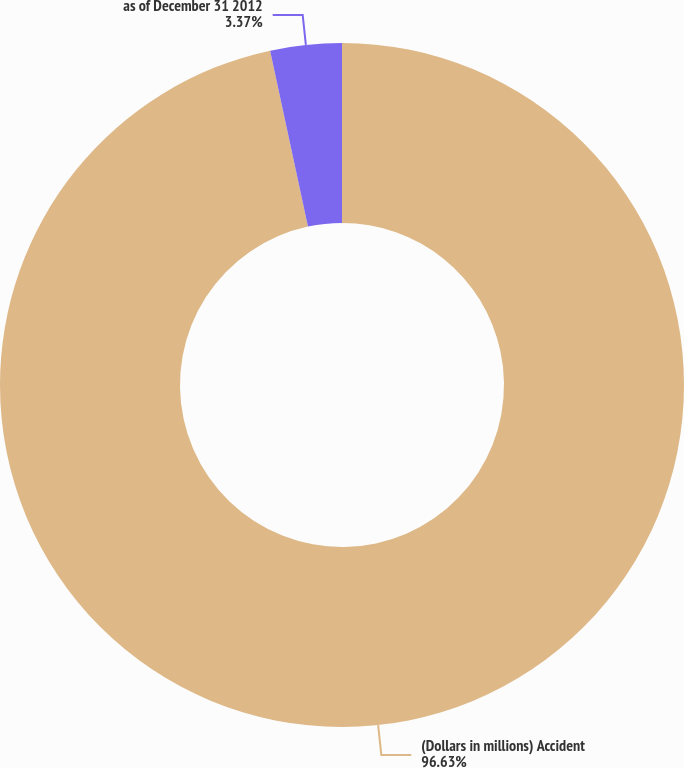<chart> <loc_0><loc_0><loc_500><loc_500><pie_chart><fcel>(Dollars in millions) Accident<fcel>as of December 31 2012<nl><fcel>96.63%<fcel>3.37%<nl></chart> 